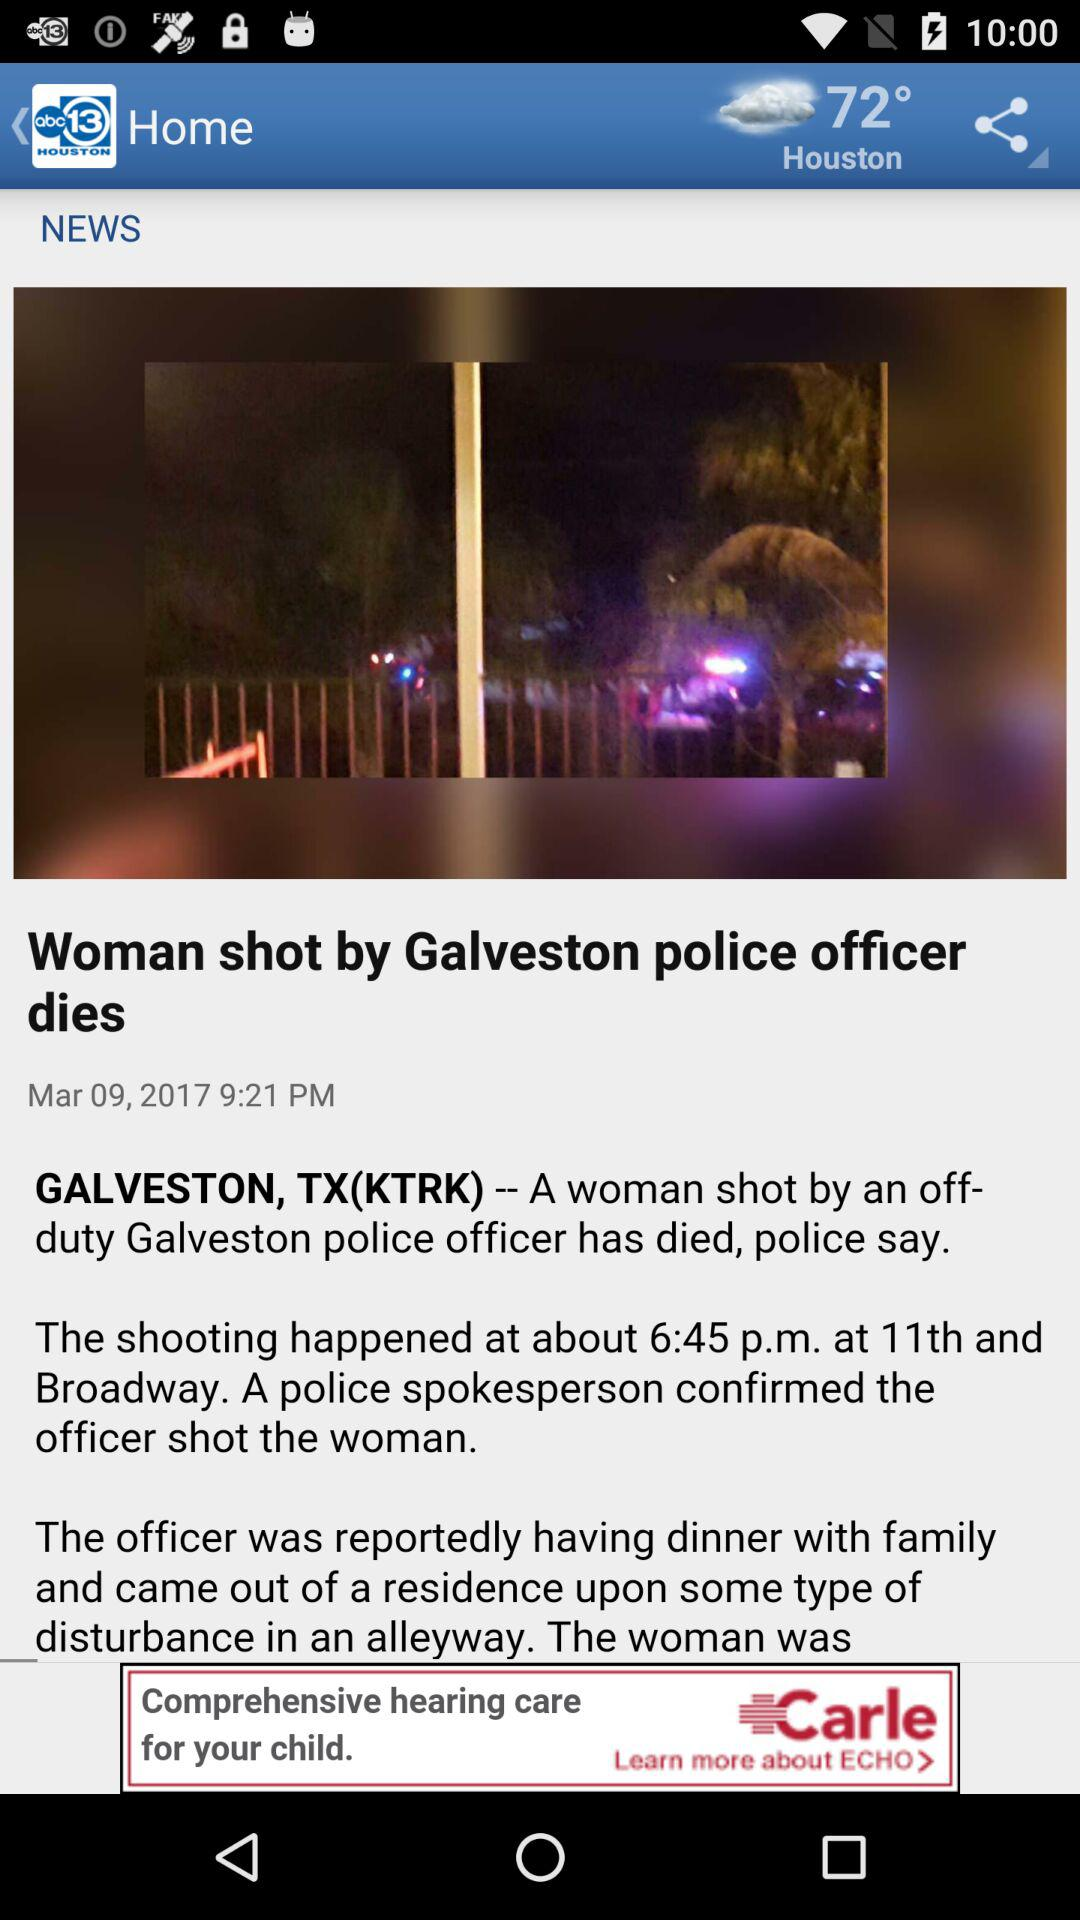What is the mentioned location? The mentioned locations are Houston and Galveston, Texas. 